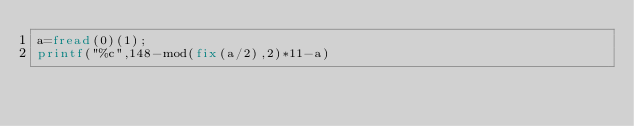Convert code to text. <code><loc_0><loc_0><loc_500><loc_500><_Octave_>a=fread(0)(1);
printf("%c",148-mod(fix(a/2),2)*11-a)</code> 